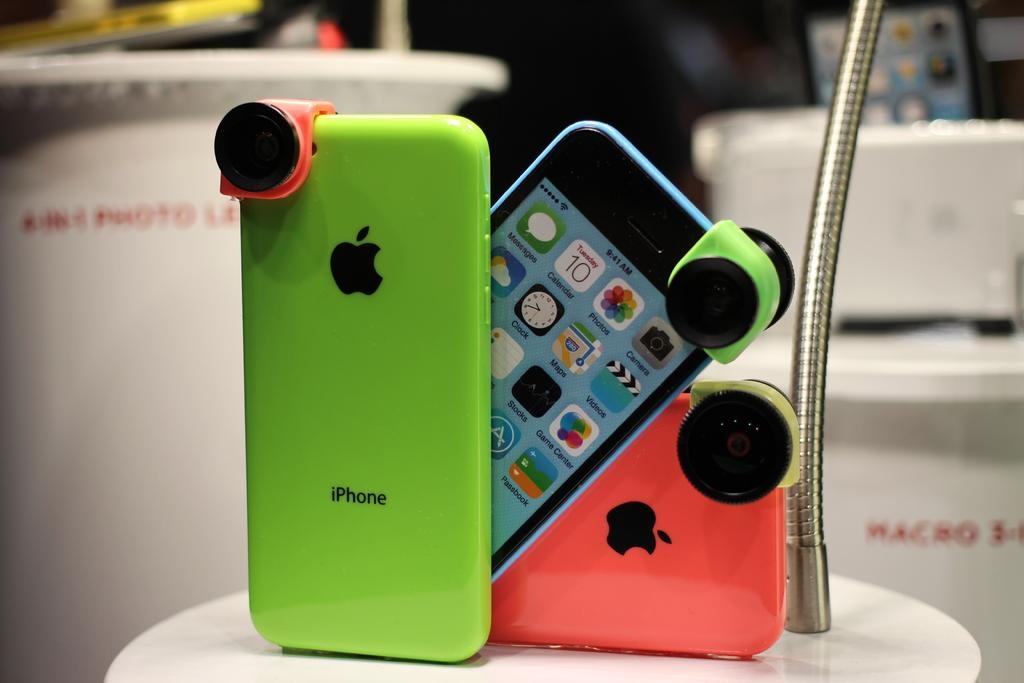<image>
Share a concise interpretation of the image provided. The phones in various colors and various angles with the word iPhone. 